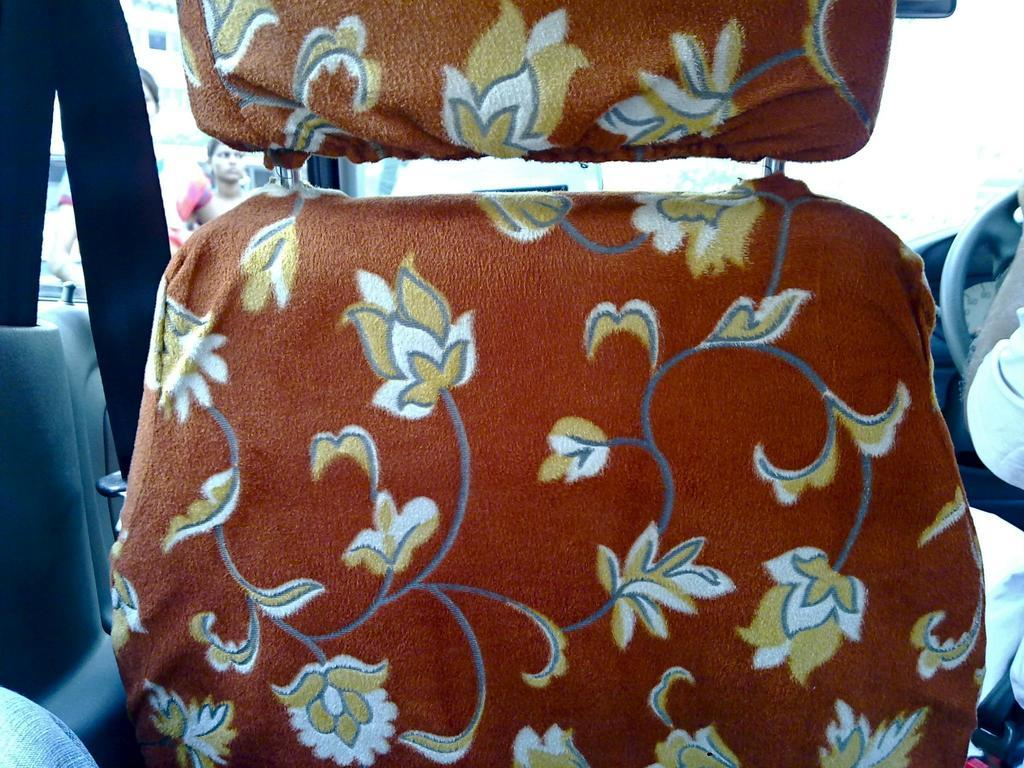What is the setting of the image? The image is of the inside of a car. Can you describe the person in the image? There is a person sitting on the right side of the car. What feature allows people to see outside the car? There is a glass (likely a window) through which people can be seen outside the car. What type of pencil is the person using to write on the office calculator in the image? There is no office, calculator, or pencil present in the image; it is a picture of the inside of a car. 